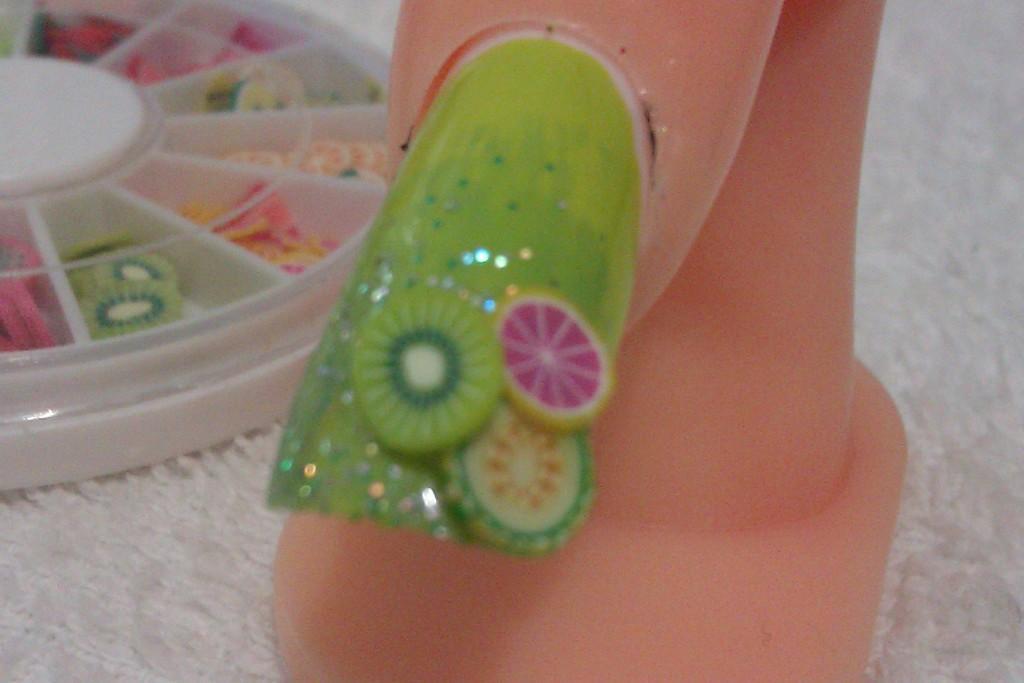Can you describe this image briefly? Here we can see an art on the nail of a finger on a stand on the cloth and on the left side there are nail art materials in a box on the cloth. 